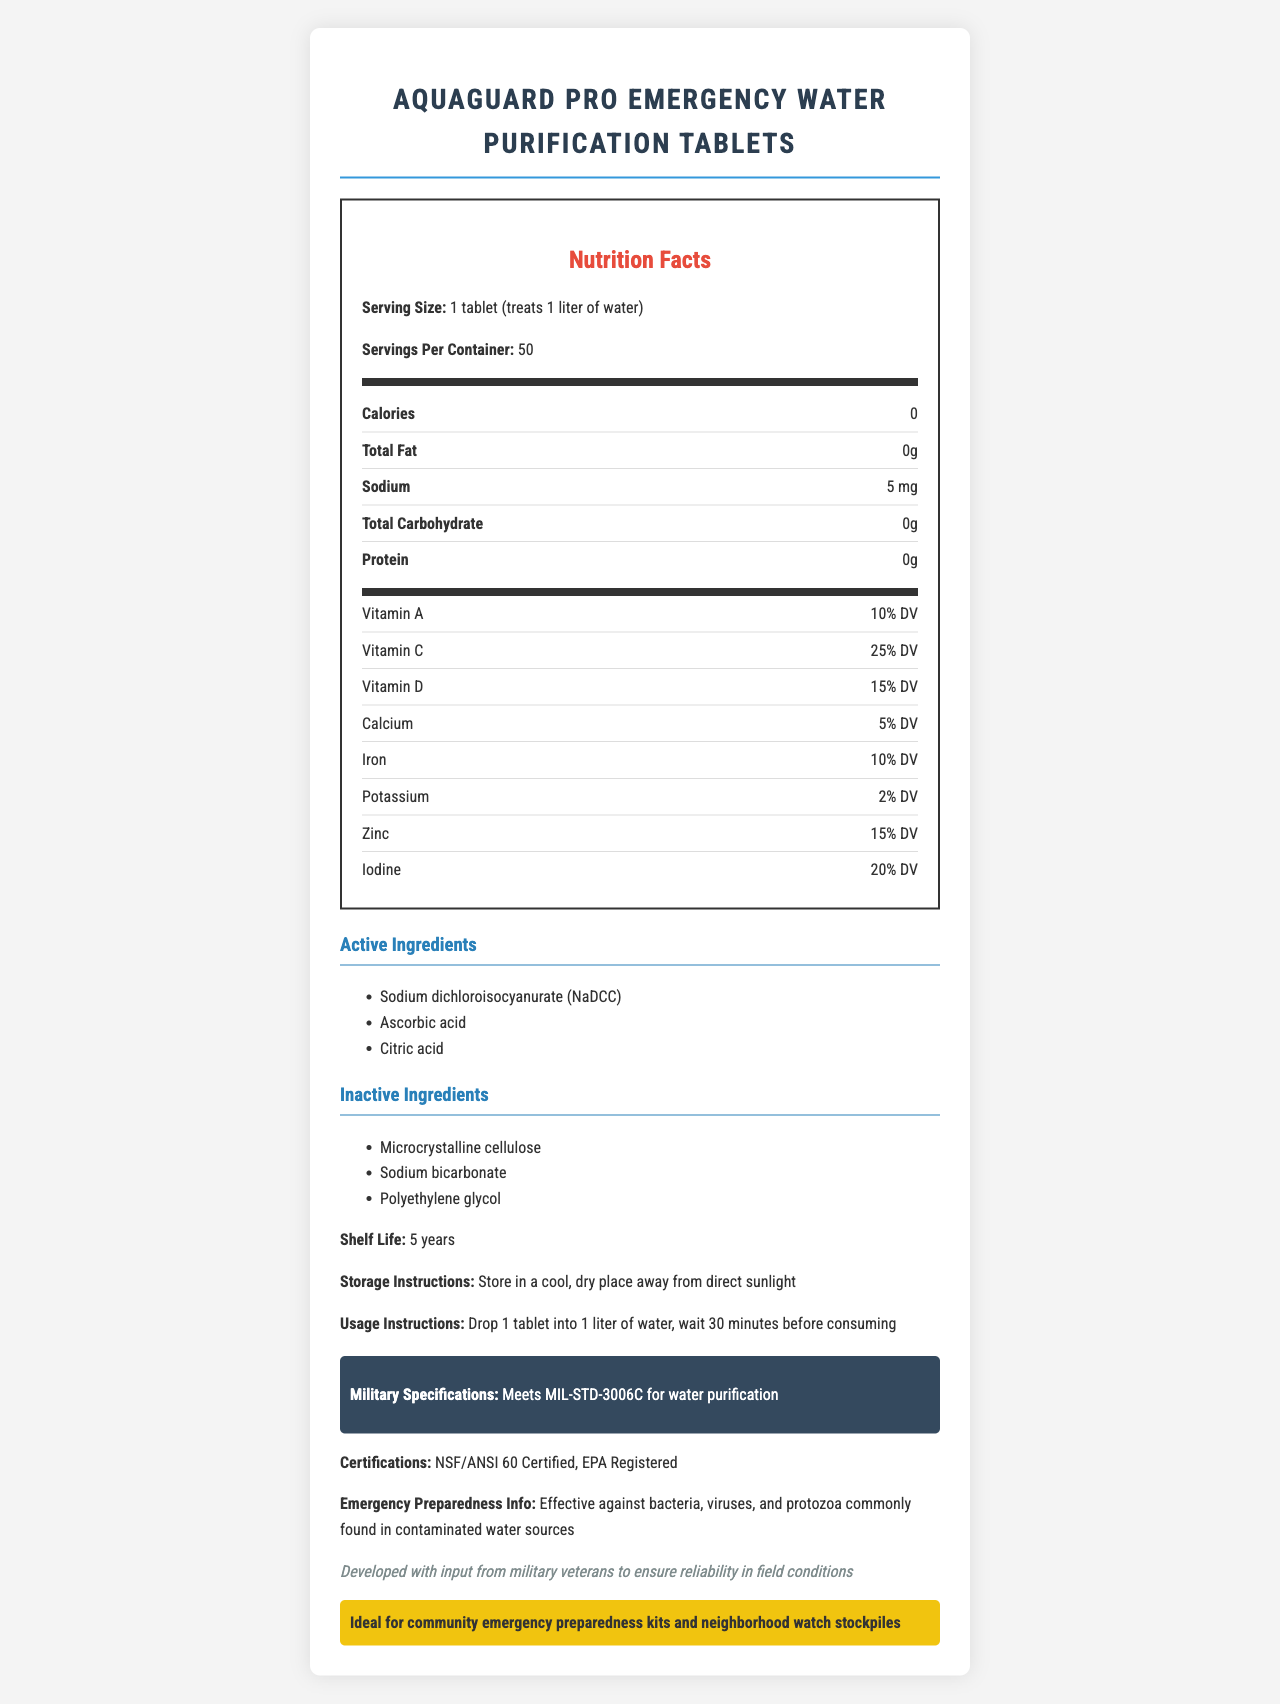what is the serving size for this product? The serving size is mentioned in the document as "1 tablet (treats 1 liter of water)".
Answer: 1 tablet (treats 1 liter of water) how many servings are in one container? The number of servings per container is given as 50.
Answer: 50 How much sodium is in one tablet? The sodium content per tablet is listed as 5 mg.
Answer: 5 mg which vitamin has the highest daily value percentage in this product? The document indicates that Vitamin C has a daily value percentage of 25%, which is the highest among the listed vitamins.
Answer: Vitamin C what are the active ingredients in this product? The active ingredients are listed as Sodium dichloroisocyanurate (NaDCC), Ascorbic acid, and Citric acid.
Answer: Sodium dichloroisocyanurate (NaDCC), Ascorbic acid, Citric acid how long is the shelf life of this product? The document specifies that the shelf life of the product is 5 years.
Answer: 5 years Which of the following is NOT an inactive ingredient in this product? A. Microcrystalline cellulose B. Sodium bicarbonate C. Ascorbic acid D. Polyethylene glycol Ascorbic acid is listed as an active ingredient, whereas Microcrystalline cellulose, Sodium bicarbonate, and Polyethylene glycol are listed as inactive ingredients.
Answer: C. Ascorbic acid what certifications does the product have? A. NSF/ANSI 60 B. EPA Registered C. Both A and B D. None The document states that the product has certifications including NSF/ANSI 60 and EPA Registered.
Answer: C. Both A and B does this product meet military specifications? The document states that the product meets MIL-STD-3006C for water purification.
Answer: Yes describe the main idea of the document The document serves as a comprehensive guide for potential users, detailing everything they need to know about the product.
Answer: The document provides detailed information on the "AquaGuard Pro Emergency Water Purification Tablets," including its nutritional facts, active and inactive ingredients, shelf life, storage instructions, usage instructions, military specifications, certifications, and emergency preparedness information. what is the storage temperature for this product? The document only states to store the product in a "cool, dry place away from direct sunlight." It does not specify an exact storage temperature.
Answer: Not enough information 